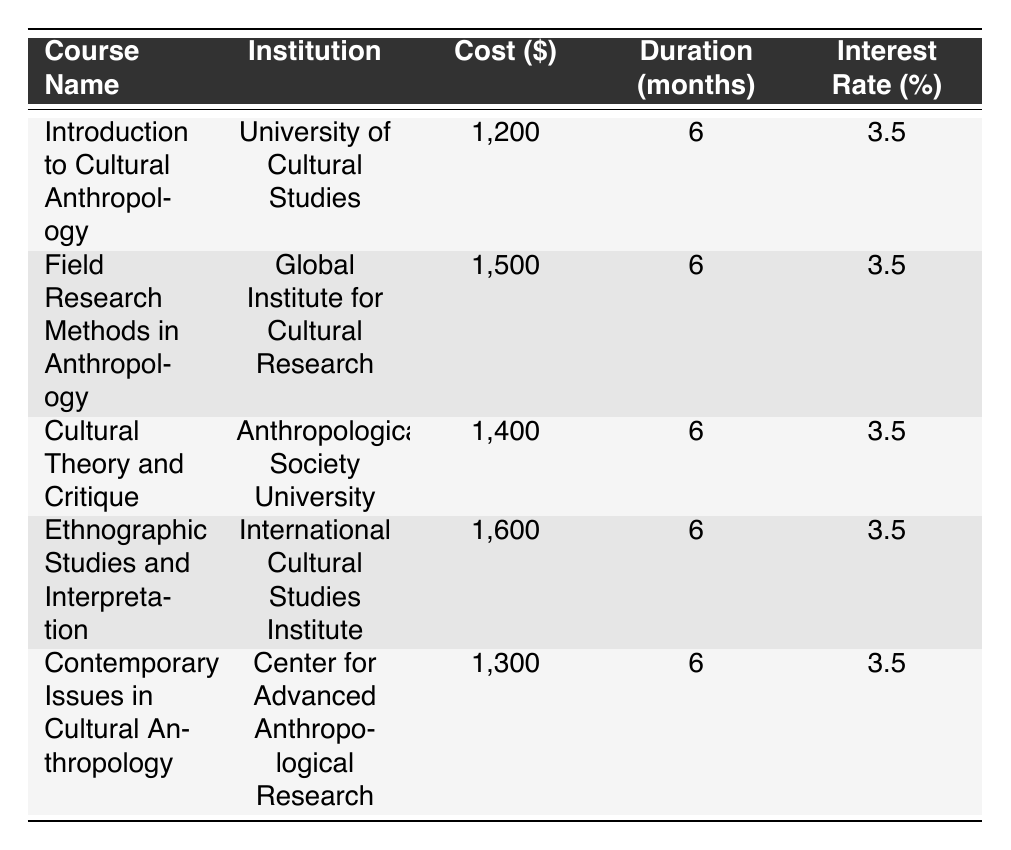What is the cost of the course "Cultural Theory and Critique"? The cost of "Cultural Theory and Critique" is listed in the table. Looking at the corresponding row, we see that the cost is 1,400.
Answer: 1,400 How many courses have a cost greater than 1,400? We can identify the courses with costs greater than 1,400 by looking at the “Cost” column. The courses are "Field Research Methods in Anthropology" (1,500), "Ethnographic Studies and Interpretation" (1,600), which gives us 2 such courses.
Answer: 2 What is the average duration of the courses listed? All courses share the same duration of 6 months. Since the duration is consistent across all courses, the average is simply 6 months as well.
Answer: 6 Is there a course named "Introduction to Cultural Anthropology"? By scanning the table, we can see that "Introduction to Cultural Anthropology" is indeed listed as one of the courses.
Answer: Yes Which course has the highest interest rate? All courses display the same interest rate of 3.5%. Therefore, no course has a higher interest rate compared to the others. It remains constant across all entries.
Answer: 3.5% What is the total cost of all courses listed? To find the total cost, we sum the individual costs: 1,200 + 1,500 + 1,400 + 1,600 + 1,300 = 7,000. Thus, the total cost is 7,000.
Answer: 7,000 How many courses are offered by the "International Cultural Studies Institute"? Only one course, "Ethnographic Studies and Interpretation," is provided by the "International Cultural Studies Institute," as confirmed by the corresponding institution in the table.
Answer: 1 Which institution offers the least expensive course? The course "Introduction to Cultural Anthropology" from the "University of Cultural Studies" has the lowest cost at 1,200. Checking all listed costs affirms this.
Answer: University of Cultural Studies What is the difference in cost between the most expensive and the least expensive course? The most expensive course is "Ethnographic Studies and Interpretation" at 1,600, and the least expensive is "Introduction to Cultural Anthropology" at 1,200. The difference is calculated as 1,600 - 1,200 = 400.
Answer: 400 